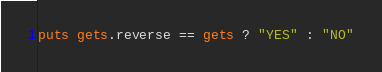<code> <loc_0><loc_0><loc_500><loc_500><_Ruby_>puts gets.reverse == gets ? "YES" : "NO"</code> 